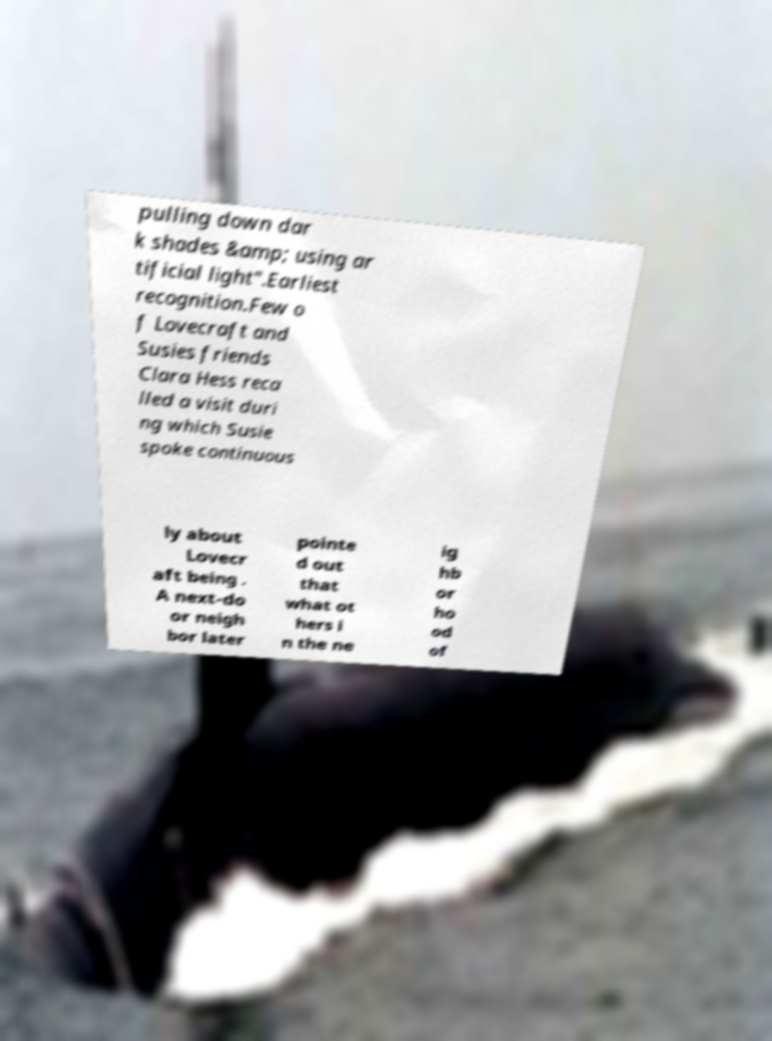Could you extract and type out the text from this image? pulling down dar k shades &amp; using ar tificial light".Earliest recognition.Few o f Lovecraft and Susies friends Clara Hess reca lled a visit duri ng which Susie spoke continuous ly about Lovecr aft being . A next-do or neigh bor later pointe d out that what ot hers i n the ne ig hb or ho od of 